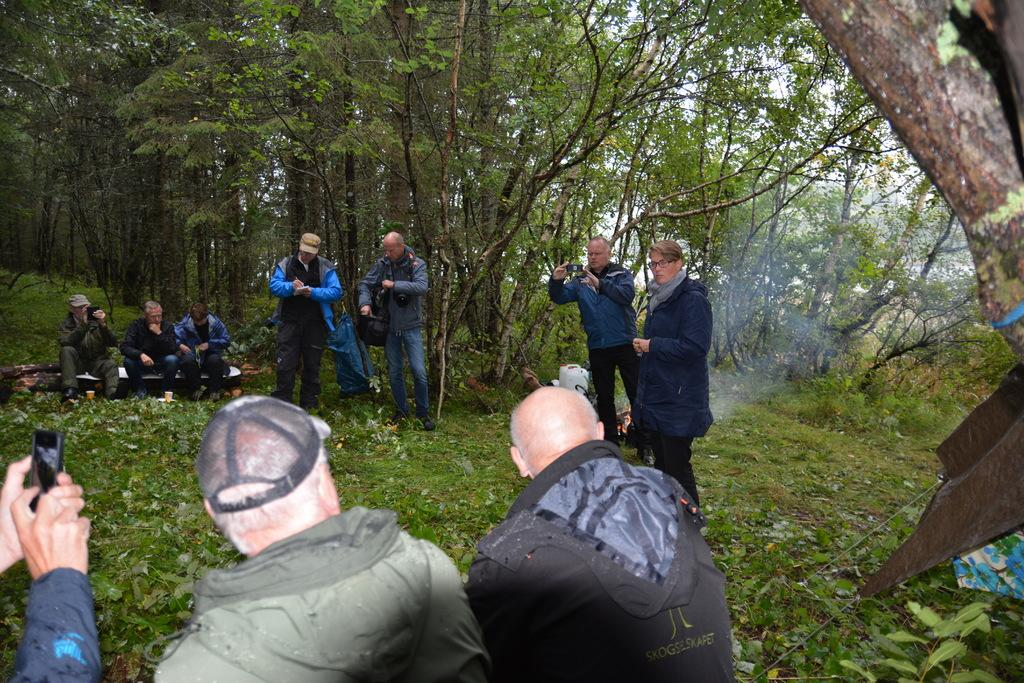What are the people in the image doing? Some people are standing, and some are sitting in the image. What objects are the people holding in their hands? The people are holding mobiles in their hands. What can be seen in the background of the image? There are trees in the background of the image. What type of vegetation is at the bottom of the image? There is grass at the bottom of the image. What type of clouds can be seen in the image? There are no clouds visible in the image; it only shows people, trees, and grass. What position is the appliance in the image? There is no appliance present in the image. 